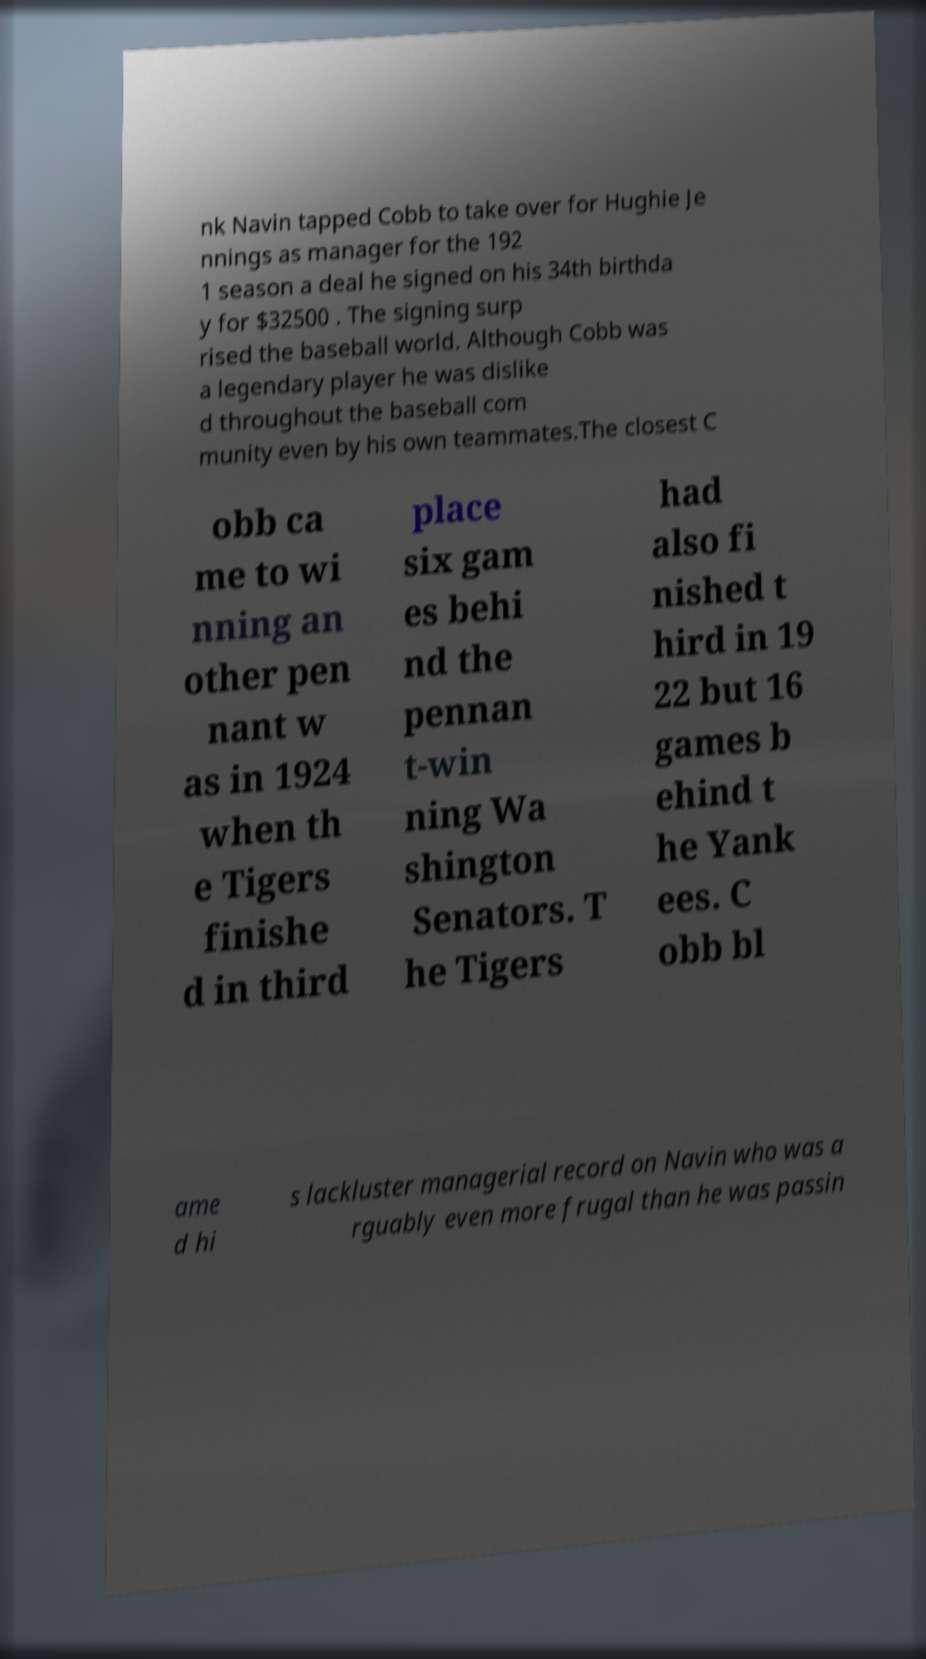Can you read and provide the text displayed in the image?This photo seems to have some interesting text. Can you extract and type it out for me? nk Navin tapped Cobb to take over for Hughie Je nnings as manager for the 192 1 season a deal he signed on his 34th birthda y for $32500 . The signing surp rised the baseball world. Although Cobb was a legendary player he was dislike d throughout the baseball com munity even by his own teammates.The closest C obb ca me to wi nning an other pen nant w as in 1924 when th e Tigers finishe d in third place six gam es behi nd the pennan t-win ning Wa shington Senators. T he Tigers had also fi nished t hird in 19 22 but 16 games b ehind t he Yank ees. C obb bl ame d hi s lackluster managerial record on Navin who was a rguably even more frugal than he was passin 